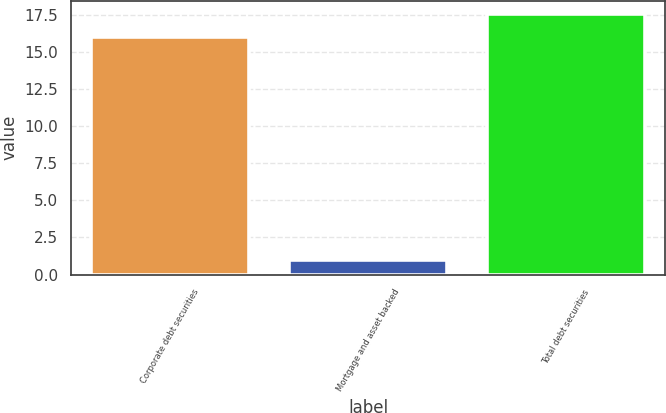Convert chart. <chart><loc_0><loc_0><loc_500><loc_500><bar_chart><fcel>Corporate debt securities<fcel>Mortgage and asset backed<fcel>Total debt securities<nl><fcel>16<fcel>1<fcel>17.6<nl></chart> 